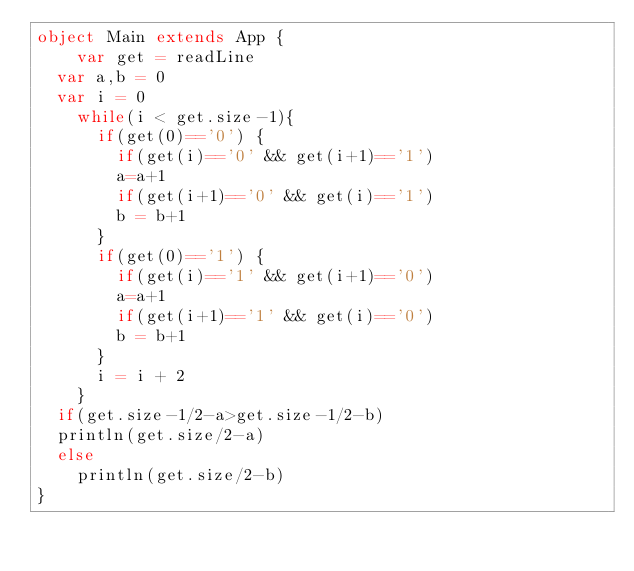<code> <loc_0><loc_0><loc_500><loc_500><_Scala_>object Main extends App {
    var get = readLine
  var a,b = 0
  var i = 0
    while(i < get.size-1){
      if(get(0)=='0') {
        if(get(i)=='0' && get(i+1)=='1')
        a=a+1
        if(get(i+1)=='0' && get(i)=='1')
        b = b+1
      }
      if(get(0)=='1') {
        if(get(i)=='1' && get(i+1)=='0')
        a=a+1
        if(get(i+1)=='1' && get(i)=='0')
        b = b+1        
      }
      i = i + 2
    }
  if(get.size-1/2-a>get.size-1/2-b)
	println(get.size/2-a)
  else
    println(get.size/2-b)
}</code> 